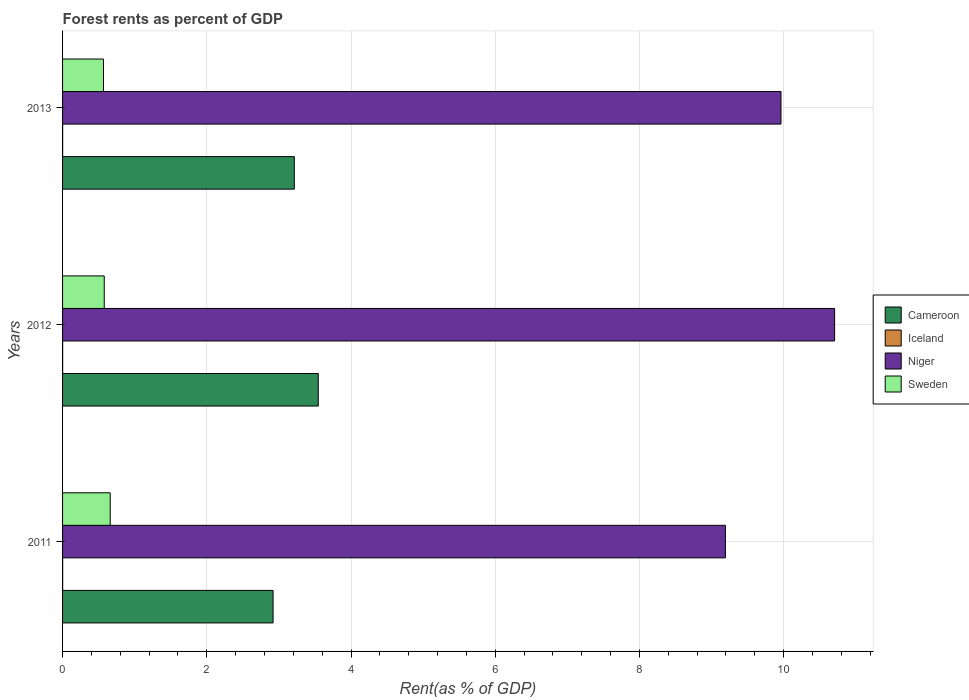How many different coloured bars are there?
Give a very brief answer. 4. Are the number of bars on each tick of the Y-axis equal?
Keep it short and to the point. Yes. What is the forest rent in Niger in 2012?
Your response must be concise. 10.71. Across all years, what is the maximum forest rent in Niger?
Provide a short and direct response. 10.71. Across all years, what is the minimum forest rent in Sweden?
Ensure brevity in your answer.  0.57. In which year was the forest rent in Niger minimum?
Ensure brevity in your answer.  2011. What is the total forest rent in Cameroon in the graph?
Provide a succinct answer. 9.68. What is the difference between the forest rent in Sweden in 2011 and that in 2013?
Make the answer very short. 0.09. What is the difference between the forest rent in Niger in 2011 and the forest rent in Iceland in 2013?
Provide a short and direct response. 9.19. What is the average forest rent in Sweden per year?
Provide a short and direct response. 0.6. In the year 2012, what is the difference between the forest rent in Sweden and forest rent in Niger?
Provide a succinct answer. -10.13. In how many years, is the forest rent in Iceland greater than 3.2 %?
Give a very brief answer. 0. What is the ratio of the forest rent in Cameroon in 2011 to that in 2012?
Provide a succinct answer. 0.82. Is the forest rent in Niger in 2012 less than that in 2013?
Ensure brevity in your answer.  No. Is the difference between the forest rent in Sweden in 2011 and 2013 greater than the difference between the forest rent in Niger in 2011 and 2013?
Provide a short and direct response. Yes. What is the difference between the highest and the second highest forest rent in Iceland?
Keep it short and to the point. 8.203084033523008e-5. What is the difference between the highest and the lowest forest rent in Sweden?
Give a very brief answer. 0.09. Is the sum of the forest rent in Iceland in 2011 and 2013 greater than the maximum forest rent in Sweden across all years?
Make the answer very short. No. What does the 1st bar from the bottom in 2012 represents?
Offer a terse response. Cameroon. Is it the case that in every year, the sum of the forest rent in Sweden and forest rent in Niger is greater than the forest rent in Iceland?
Give a very brief answer. Yes. How many years are there in the graph?
Make the answer very short. 3. Are the values on the major ticks of X-axis written in scientific E-notation?
Provide a succinct answer. No. Does the graph contain any zero values?
Your response must be concise. No. Does the graph contain grids?
Offer a terse response. Yes. Where does the legend appear in the graph?
Make the answer very short. Center right. How many legend labels are there?
Your response must be concise. 4. What is the title of the graph?
Ensure brevity in your answer.  Forest rents as percent of GDP. What is the label or title of the X-axis?
Offer a terse response. Rent(as % of GDP). What is the Rent(as % of GDP) of Cameroon in 2011?
Keep it short and to the point. 2.92. What is the Rent(as % of GDP) of Iceland in 2011?
Your response must be concise. 0. What is the Rent(as % of GDP) of Niger in 2011?
Offer a very short reply. 9.19. What is the Rent(as % of GDP) of Sweden in 2011?
Ensure brevity in your answer.  0.66. What is the Rent(as % of GDP) in Cameroon in 2012?
Offer a terse response. 3.55. What is the Rent(as % of GDP) in Iceland in 2012?
Offer a terse response. 0. What is the Rent(as % of GDP) in Niger in 2012?
Your answer should be very brief. 10.71. What is the Rent(as % of GDP) of Sweden in 2012?
Provide a succinct answer. 0.58. What is the Rent(as % of GDP) of Cameroon in 2013?
Your answer should be very brief. 3.21. What is the Rent(as % of GDP) of Iceland in 2013?
Provide a succinct answer. 0. What is the Rent(as % of GDP) in Niger in 2013?
Offer a very short reply. 9.96. What is the Rent(as % of GDP) of Sweden in 2013?
Provide a short and direct response. 0.57. Across all years, what is the maximum Rent(as % of GDP) in Cameroon?
Your response must be concise. 3.55. Across all years, what is the maximum Rent(as % of GDP) of Iceland?
Your response must be concise. 0. Across all years, what is the maximum Rent(as % of GDP) in Niger?
Ensure brevity in your answer.  10.71. Across all years, what is the maximum Rent(as % of GDP) of Sweden?
Offer a terse response. 0.66. Across all years, what is the minimum Rent(as % of GDP) in Cameroon?
Your response must be concise. 2.92. Across all years, what is the minimum Rent(as % of GDP) of Iceland?
Give a very brief answer. 0. Across all years, what is the minimum Rent(as % of GDP) in Niger?
Your answer should be compact. 9.19. Across all years, what is the minimum Rent(as % of GDP) in Sweden?
Provide a short and direct response. 0.57. What is the total Rent(as % of GDP) of Cameroon in the graph?
Offer a very short reply. 9.68. What is the total Rent(as % of GDP) of Iceland in the graph?
Your answer should be very brief. 0. What is the total Rent(as % of GDP) in Niger in the graph?
Provide a succinct answer. 29.86. What is the total Rent(as % of GDP) of Sweden in the graph?
Your answer should be compact. 1.81. What is the difference between the Rent(as % of GDP) of Cameroon in 2011 and that in 2012?
Provide a short and direct response. -0.63. What is the difference between the Rent(as % of GDP) of Iceland in 2011 and that in 2012?
Your answer should be very brief. 0. What is the difference between the Rent(as % of GDP) of Niger in 2011 and that in 2012?
Make the answer very short. -1.51. What is the difference between the Rent(as % of GDP) of Sweden in 2011 and that in 2012?
Offer a terse response. 0.08. What is the difference between the Rent(as % of GDP) of Cameroon in 2011 and that in 2013?
Provide a succinct answer. -0.29. What is the difference between the Rent(as % of GDP) of Niger in 2011 and that in 2013?
Your answer should be very brief. -0.77. What is the difference between the Rent(as % of GDP) of Sweden in 2011 and that in 2013?
Provide a succinct answer. 0.09. What is the difference between the Rent(as % of GDP) of Cameroon in 2012 and that in 2013?
Provide a short and direct response. 0.33. What is the difference between the Rent(as % of GDP) of Niger in 2012 and that in 2013?
Your answer should be compact. 0.74. What is the difference between the Rent(as % of GDP) in Sweden in 2012 and that in 2013?
Your answer should be very brief. 0.01. What is the difference between the Rent(as % of GDP) in Cameroon in 2011 and the Rent(as % of GDP) in Iceland in 2012?
Offer a very short reply. 2.92. What is the difference between the Rent(as % of GDP) in Cameroon in 2011 and the Rent(as % of GDP) in Niger in 2012?
Your answer should be very brief. -7.79. What is the difference between the Rent(as % of GDP) in Cameroon in 2011 and the Rent(as % of GDP) in Sweden in 2012?
Offer a terse response. 2.34. What is the difference between the Rent(as % of GDP) of Iceland in 2011 and the Rent(as % of GDP) of Niger in 2012?
Offer a very short reply. -10.71. What is the difference between the Rent(as % of GDP) of Iceland in 2011 and the Rent(as % of GDP) of Sweden in 2012?
Provide a short and direct response. -0.58. What is the difference between the Rent(as % of GDP) in Niger in 2011 and the Rent(as % of GDP) in Sweden in 2012?
Ensure brevity in your answer.  8.61. What is the difference between the Rent(as % of GDP) of Cameroon in 2011 and the Rent(as % of GDP) of Iceland in 2013?
Provide a succinct answer. 2.92. What is the difference between the Rent(as % of GDP) of Cameroon in 2011 and the Rent(as % of GDP) of Niger in 2013?
Your answer should be very brief. -7.04. What is the difference between the Rent(as % of GDP) in Cameroon in 2011 and the Rent(as % of GDP) in Sweden in 2013?
Your response must be concise. 2.35. What is the difference between the Rent(as % of GDP) of Iceland in 2011 and the Rent(as % of GDP) of Niger in 2013?
Your response must be concise. -9.96. What is the difference between the Rent(as % of GDP) of Iceland in 2011 and the Rent(as % of GDP) of Sweden in 2013?
Your answer should be compact. -0.57. What is the difference between the Rent(as % of GDP) in Niger in 2011 and the Rent(as % of GDP) in Sweden in 2013?
Provide a short and direct response. 8.62. What is the difference between the Rent(as % of GDP) of Cameroon in 2012 and the Rent(as % of GDP) of Iceland in 2013?
Make the answer very short. 3.54. What is the difference between the Rent(as % of GDP) in Cameroon in 2012 and the Rent(as % of GDP) in Niger in 2013?
Give a very brief answer. -6.42. What is the difference between the Rent(as % of GDP) of Cameroon in 2012 and the Rent(as % of GDP) of Sweden in 2013?
Provide a succinct answer. 2.98. What is the difference between the Rent(as % of GDP) in Iceland in 2012 and the Rent(as % of GDP) in Niger in 2013?
Make the answer very short. -9.96. What is the difference between the Rent(as % of GDP) in Iceland in 2012 and the Rent(as % of GDP) in Sweden in 2013?
Give a very brief answer. -0.57. What is the difference between the Rent(as % of GDP) of Niger in 2012 and the Rent(as % of GDP) of Sweden in 2013?
Offer a terse response. 10.14. What is the average Rent(as % of GDP) of Cameroon per year?
Keep it short and to the point. 3.23. What is the average Rent(as % of GDP) in Iceland per year?
Offer a very short reply. 0. What is the average Rent(as % of GDP) in Niger per year?
Provide a succinct answer. 9.95. What is the average Rent(as % of GDP) of Sweden per year?
Offer a terse response. 0.6. In the year 2011, what is the difference between the Rent(as % of GDP) in Cameroon and Rent(as % of GDP) in Iceland?
Provide a short and direct response. 2.92. In the year 2011, what is the difference between the Rent(as % of GDP) of Cameroon and Rent(as % of GDP) of Niger?
Offer a very short reply. -6.27. In the year 2011, what is the difference between the Rent(as % of GDP) in Cameroon and Rent(as % of GDP) in Sweden?
Your answer should be compact. 2.26. In the year 2011, what is the difference between the Rent(as % of GDP) of Iceland and Rent(as % of GDP) of Niger?
Keep it short and to the point. -9.19. In the year 2011, what is the difference between the Rent(as % of GDP) of Iceland and Rent(as % of GDP) of Sweden?
Provide a succinct answer. -0.66. In the year 2011, what is the difference between the Rent(as % of GDP) in Niger and Rent(as % of GDP) in Sweden?
Make the answer very short. 8.53. In the year 2012, what is the difference between the Rent(as % of GDP) in Cameroon and Rent(as % of GDP) in Iceland?
Your answer should be very brief. 3.54. In the year 2012, what is the difference between the Rent(as % of GDP) of Cameroon and Rent(as % of GDP) of Niger?
Make the answer very short. -7.16. In the year 2012, what is the difference between the Rent(as % of GDP) of Cameroon and Rent(as % of GDP) of Sweden?
Your response must be concise. 2.97. In the year 2012, what is the difference between the Rent(as % of GDP) in Iceland and Rent(as % of GDP) in Niger?
Provide a short and direct response. -10.71. In the year 2012, what is the difference between the Rent(as % of GDP) in Iceland and Rent(as % of GDP) in Sweden?
Make the answer very short. -0.58. In the year 2012, what is the difference between the Rent(as % of GDP) in Niger and Rent(as % of GDP) in Sweden?
Keep it short and to the point. 10.13. In the year 2013, what is the difference between the Rent(as % of GDP) in Cameroon and Rent(as % of GDP) in Iceland?
Your response must be concise. 3.21. In the year 2013, what is the difference between the Rent(as % of GDP) of Cameroon and Rent(as % of GDP) of Niger?
Give a very brief answer. -6.75. In the year 2013, what is the difference between the Rent(as % of GDP) in Cameroon and Rent(as % of GDP) in Sweden?
Give a very brief answer. 2.65. In the year 2013, what is the difference between the Rent(as % of GDP) in Iceland and Rent(as % of GDP) in Niger?
Offer a terse response. -9.96. In the year 2013, what is the difference between the Rent(as % of GDP) in Iceland and Rent(as % of GDP) in Sweden?
Your answer should be very brief. -0.57. In the year 2013, what is the difference between the Rent(as % of GDP) of Niger and Rent(as % of GDP) of Sweden?
Give a very brief answer. 9.4. What is the ratio of the Rent(as % of GDP) of Cameroon in 2011 to that in 2012?
Ensure brevity in your answer.  0.82. What is the ratio of the Rent(as % of GDP) in Iceland in 2011 to that in 2012?
Offer a terse response. 1.07. What is the ratio of the Rent(as % of GDP) of Niger in 2011 to that in 2012?
Provide a succinct answer. 0.86. What is the ratio of the Rent(as % of GDP) in Sweden in 2011 to that in 2012?
Provide a succinct answer. 1.14. What is the ratio of the Rent(as % of GDP) in Cameroon in 2011 to that in 2013?
Offer a very short reply. 0.91. What is the ratio of the Rent(as % of GDP) in Iceland in 2011 to that in 2013?
Provide a succinct answer. 1.08. What is the ratio of the Rent(as % of GDP) of Niger in 2011 to that in 2013?
Your response must be concise. 0.92. What is the ratio of the Rent(as % of GDP) of Sweden in 2011 to that in 2013?
Provide a short and direct response. 1.16. What is the ratio of the Rent(as % of GDP) in Cameroon in 2012 to that in 2013?
Your answer should be compact. 1.1. What is the ratio of the Rent(as % of GDP) in Niger in 2012 to that in 2013?
Make the answer very short. 1.07. What is the ratio of the Rent(as % of GDP) in Sweden in 2012 to that in 2013?
Your answer should be compact. 1.02. What is the difference between the highest and the second highest Rent(as % of GDP) in Cameroon?
Your answer should be very brief. 0.33. What is the difference between the highest and the second highest Rent(as % of GDP) in Niger?
Offer a terse response. 0.74. What is the difference between the highest and the second highest Rent(as % of GDP) of Sweden?
Offer a terse response. 0.08. What is the difference between the highest and the lowest Rent(as % of GDP) in Cameroon?
Ensure brevity in your answer.  0.63. What is the difference between the highest and the lowest Rent(as % of GDP) of Niger?
Your response must be concise. 1.51. What is the difference between the highest and the lowest Rent(as % of GDP) in Sweden?
Make the answer very short. 0.09. 